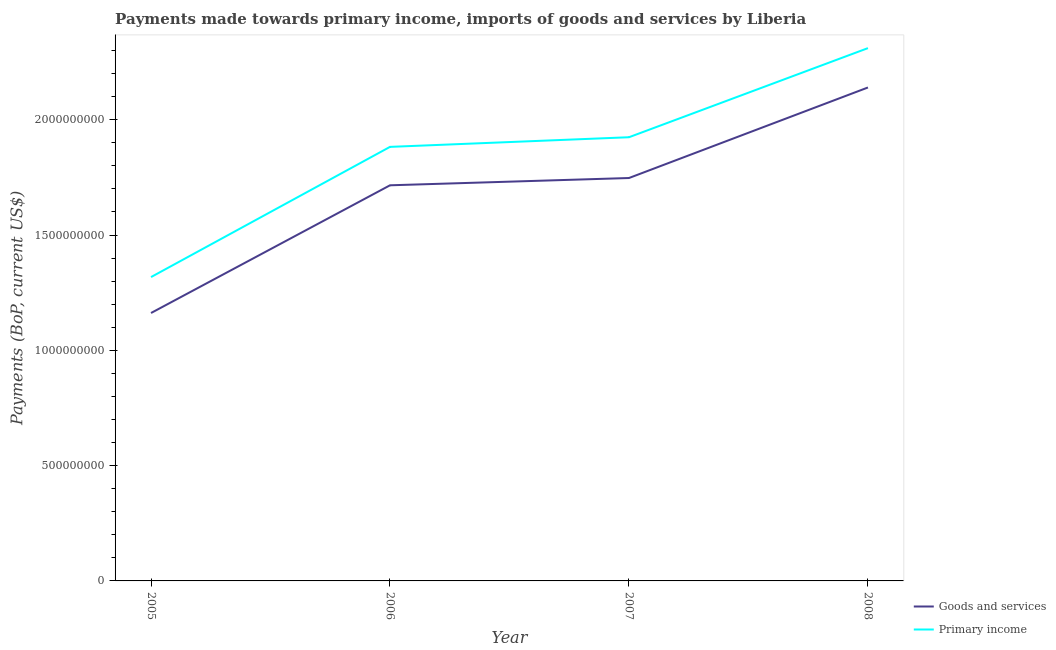Is the number of lines equal to the number of legend labels?
Your response must be concise. Yes. What is the payments made towards goods and services in 2006?
Offer a terse response. 1.72e+09. Across all years, what is the maximum payments made towards primary income?
Your answer should be very brief. 2.31e+09. Across all years, what is the minimum payments made towards goods and services?
Your answer should be very brief. 1.16e+09. In which year was the payments made towards goods and services minimum?
Your answer should be very brief. 2005. What is the total payments made towards primary income in the graph?
Your response must be concise. 7.43e+09. What is the difference between the payments made towards primary income in 2005 and that in 2006?
Offer a very short reply. -5.65e+08. What is the difference between the payments made towards goods and services in 2006 and the payments made towards primary income in 2008?
Provide a succinct answer. -5.95e+08. What is the average payments made towards goods and services per year?
Your response must be concise. 1.69e+09. In the year 2008, what is the difference between the payments made towards primary income and payments made towards goods and services?
Ensure brevity in your answer.  1.71e+08. What is the ratio of the payments made towards primary income in 2007 to that in 2008?
Your answer should be very brief. 0.83. What is the difference between the highest and the second highest payments made towards goods and services?
Give a very brief answer. 3.93e+08. What is the difference between the highest and the lowest payments made towards goods and services?
Ensure brevity in your answer.  9.78e+08. In how many years, is the payments made towards primary income greater than the average payments made towards primary income taken over all years?
Keep it short and to the point. 3. How many lines are there?
Provide a succinct answer. 2. How many years are there in the graph?
Provide a short and direct response. 4. What is the difference between two consecutive major ticks on the Y-axis?
Offer a very short reply. 5.00e+08. How are the legend labels stacked?
Give a very brief answer. Vertical. What is the title of the graph?
Give a very brief answer. Payments made towards primary income, imports of goods and services by Liberia. Does "Goods" appear as one of the legend labels in the graph?
Offer a terse response. No. What is the label or title of the Y-axis?
Make the answer very short. Payments (BoP, current US$). What is the Payments (BoP, current US$) in Goods and services in 2005?
Provide a short and direct response. 1.16e+09. What is the Payments (BoP, current US$) of Primary income in 2005?
Offer a terse response. 1.32e+09. What is the Payments (BoP, current US$) of Goods and services in 2006?
Provide a short and direct response. 1.72e+09. What is the Payments (BoP, current US$) in Primary income in 2006?
Provide a short and direct response. 1.88e+09. What is the Payments (BoP, current US$) of Goods and services in 2007?
Keep it short and to the point. 1.75e+09. What is the Payments (BoP, current US$) of Primary income in 2007?
Your answer should be compact. 1.92e+09. What is the Payments (BoP, current US$) of Goods and services in 2008?
Provide a succinct answer. 2.14e+09. What is the Payments (BoP, current US$) in Primary income in 2008?
Offer a terse response. 2.31e+09. Across all years, what is the maximum Payments (BoP, current US$) of Goods and services?
Your response must be concise. 2.14e+09. Across all years, what is the maximum Payments (BoP, current US$) in Primary income?
Ensure brevity in your answer.  2.31e+09. Across all years, what is the minimum Payments (BoP, current US$) of Goods and services?
Your response must be concise. 1.16e+09. Across all years, what is the minimum Payments (BoP, current US$) in Primary income?
Your response must be concise. 1.32e+09. What is the total Payments (BoP, current US$) of Goods and services in the graph?
Make the answer very short. 6.76e+09. What is the total Payments (BoP, current US$) of Primary income in the graph?
Your answer should be compact. 7.43e+09. What is the difference between the Payments (BoP, current US$) in Goods and services in 2005 and that in 2006?
Offer a very short reply. -5.54e+08. What is the difference between the Payments (BoP, current US$) of Primary income in 2005 and that in 2006?
Offer a very short reply. -5.65e+08. What is the difference between the Payments (BoP, current US$) of Goods and services in 2005 and that in 2007?
Give a very brief answer. -5.85e+08. What is the difference between the Payments (BoP, current US$) in Primary income in 2005 and that in 2007?
Ensure brevity in your answer.  -6.06e+08. What is the difference between the Payments (BoP, current US$) in Goods and services in 2005 and that in 2008?
Your answer should be very brief. -9.78e+08. What is the difference between the Payments (BoP, current US$) in Primary income in 2005 and that in 2008?
Make the answer very short. -9.93e+08. What is the difference between the Payments (BoP, current US$) of Goods and services in 2006 and that in 2007?
Provide a succinct answer. -3.16e+07. What is the difference between the Payments (BoP, current US$) in Primary income in 2006 and that in 2007?
Your response must be concise. -4.18e+07. What is the difference between the Payments (BoP, current US$) of Goods and services in 2006 and that in 2008?
Your answer should be compact. -4.24e+08. What is the difference between the Payments (BoP, current US$) of Primary income in 2006 and that in 2008?
Give a very brief answer. -4.28e+08. What is the difference between the Payments (BoP, current US$) in Goods and services in 2007 and that in 2008?
Ensure brevity in your answer.  -3.93e+08. What is the difference between the Payments (BoP, current US$) in Primary income in 2007 and that in 2008?
Keep it short and to the point. -3.86e+08. What is the difference between the Payments (BoP, current US$) of Goods and services in 2005 and the Payments (BoP, current US$) of Primary income in 2006?
Offer a very short reply. -7.21e+08. What is the difference between the Payments (BoP, current US$) of Goods and services in 2005 and the Payments (BoP, current US$) of Primary income in 2007?
Offer a very short reply. -7.62e+08. What is the difference between the Payments (BoP, current US$) of Goods and services in 2005 and the Payments (BoP, current US$) of Primary income in 2008?
Ensure brevity in your answer.  -1.15e+09. What is the difference between the Payments (BoP, current US$) of Goods and services in 2006 and the Payments (BoP, current US$) of Primary income in 2007?
Your response must be concise. -2.08e+08. What is the difference between the Payments (BoP, current US$) of Goods and services in 2006 and the Payments (BoP, current US$) of Primary income in 2008?
Provide a short and direct response. -5.95e+08. What is the difference between the Payments (BoP, current US$) of Goods and services in 2007 and the Payments (BoP, current US$) of Primary income in 2008?
Offer a terse response. -5.63e+08. What is the average Payments (BoP, current US$) of Goods and services per year?
Make the answer very short. 1.69e+09. What is the average Payments (BoP, current US$) in Primary income per year?
Offer a terse response. 1.86e+09. In the year 2005, what is the difference between the Payments (BoP, current US$) of Goods and services and Payments (BoP, current US$) of Primary income?
Your response must be concise. -1.56e+08. In the year 2006, what is the difference between the Payments (BoP, current US$) in Goods and services and Payments (BoP, current US$) in Primary income?
Offer a very short reply. -1.67e+08. In the year 2007, what is the difference between the Payments (BoP, current US$) in Goods and services and Payments (BoP, current US$) in Primary income?
Offer a very short reply. -1.77e+08. In the year 2008, what is the difference between the Payments (BoP, current US$) of Goods and services and Payments (BoP, current US$) of Primary income?
Your answer should be compact. -1.71e+08. What is the ratio of the Payments (BoP, current US$) of Goods and services in 2005 to that in 2006?
Your answer should be very brief. 0.68. What is the ratio of the Payments (BoP, current US$) in Goods and services in 2005 to that in 2007?
Your answer should be compact. 0.66. What is the ratio of the Payments (BoP, current US$) of Primary income in 2005 to that in 2007?
Your answer should be compact. 0.68. What is the ratio of the Payments (BoP, current US$) of Goods and services in 2005 to that in 2008?
Offer a terse response. 0.54. What is the ratio of the Payments (BoP, current US$) of Primary income in 2005 to that in 2008?
Offer a very short reply. 0.57. What is the ratio of the Payments (BoP, current US$) in Goods and services in 2006 to that in 2007?
Make the answer very short. 0.98. What is the ratio of the Payments (BoP, current US$) in Primary income in 2006 to that in 2007?
Offer a very short reply. 0.98. What is the ratio of the Payments (BoP, current US$) in Goods and services in 2006 to that in 2008?
Ensure brevity in your answer.  0.8. What is the ratio of the Payments (BoP, current US$) of Primary income in 2006 to that in 2008?
Your response must be concise. 0.81. What is the ratio of the Payments (BoP, current US$) in Goods and services in 2007 to that in 2008?
Provide a short and direct response. 0.82. What is the ratio of the Payments (BoP, current US$) of Primary income in 2007 to that in 2008?
Your response must be concise. 0.83. What is the difference between the highest and the second highest Payments (BoP, current US$) of Goods and services?
Make the answer very short. 3.93e+08. What is the difference between the highest and the second highest Payments (BoP, current US$) in Primary income?
Your response must be concise. 3.86e+08. What is the difference between the highest and the lowest Payments (BoP, current US$) in Goods and services?
Ensure brevity in your answer.  9.78e+08. What is the difference between the highest and the lowest Payments (BoP, current US$) of Primary income?
Ensure brevity in your answer.  9.93e+08. 